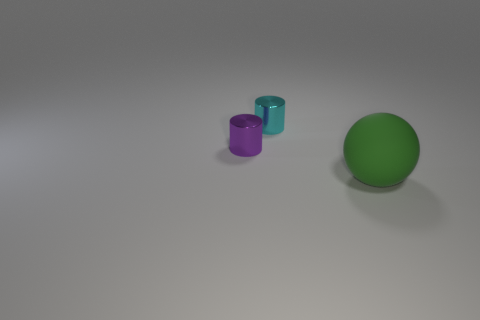Add 3 large purple matte cylinders. How many objects exist? 6 Subtract all spheres. How many objects are left? 2 Add 2 red rubber things. How many red rubber things exist? 2 Subtract 0 brown balls. How many objects are left? 3 Subtract all tiny brown shiny spheres. Subtract all small purple metallic cylinders. How many objects are left? 2 Add 1 large green matte balls. How many large green matte balls are left? 2 